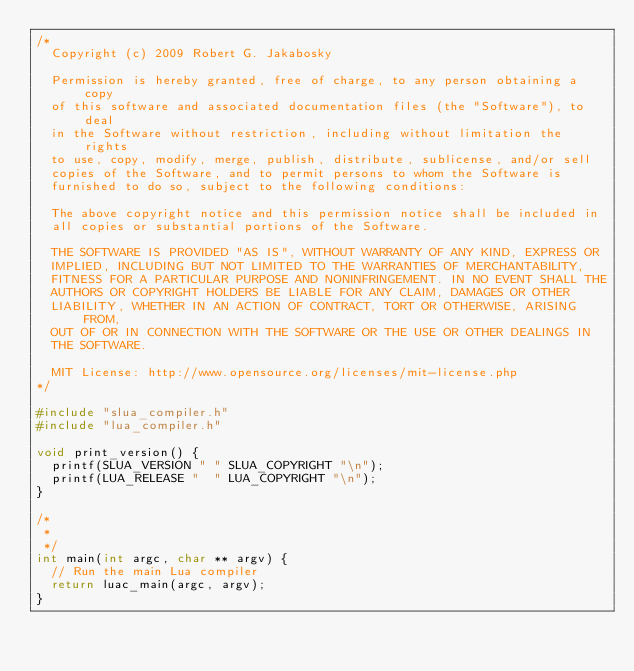Convert code to text. <code><loc_0><loc_0><loc_500><loc_500><_C_>/*
  Copyright (c) 2009 Robert G. Jakabosky
  
  Permission is hereby granted, free of charge, to any person obtaining a copy
  of this software and associated documentation files (the "Software"), to deal
  in the Software without restriction, including without limitation the rights
  to use, copy, modify, merge, publish, distribute, sublicense, and/or sell
  copies of the Software, and to permit persons to whom the Software is
  furnished to do so, subject to the following conditions:
  
  The above copyright notice and this permission notice shall be included in
  all copies or substantial portions of the Software.
  
  THE SOFTWARE IS PROVIDED "AS IS", WITHOUT WARRANTY OF ANY KIND, EXPRESS OR
  IMPLIED, INCLUDING BUT NOT LIMITED TO THE WARRANTIES OF MERCHANTABILITY,
  FITNESS FOR A PARTICULAR PURPOSE AND NONINFRINGEMENT. IN NO EVENT SHALL THE
  AUTHORS OR COPYRIGHT HOLDERS BE LIABLE FOR ANY CLAIM, DAMAGES OR OTHER
  LIABILITY, WHETHER IN AN ACTION OF CONTRACT, TORT OR OTHERWISE, ARISING FROM,
  OUT OF OR IN CONNECTION WITH THE SOFTWARE OR THE USE OR OTHER DEALINGS IN
  THE SOFTWARE.

  MIT License: http://www.opensource.org/licenses/mit-license.php
*/

#include "slua_compiler.h"
#include "lua_compiler.h"

void print_version() {
	printf(SLUA_VERSION " " SLUA_COPYRIGHT "\n");
	printf(LUA_RELEASE "  " LUA_COPYRIGHT "\n");
}

/*
 *
 */
int main(int argc, char ** argv) {
	// Run the main Lua compiler
	return luac_main(argc, argv);
}

</code> 